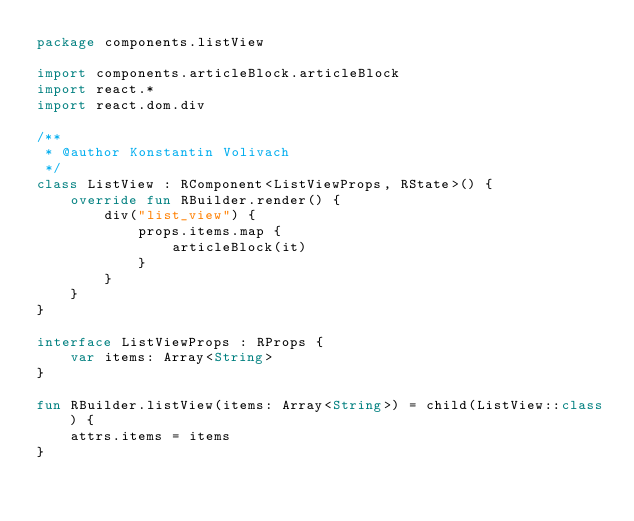<code> <loc_0><loc_0><loc_500><loc_500><_Kotlin_>package components.listView

import components.articleBlock.articleBlock
import react.*
import react.dom.div

/**
 * @author Konstantin Volivach
 */
class ListView : RComponent<ListViewProps, RState>() {
    override fun RBuilder.render() {
        div("list_view") {
            props.items.map {
                articleBlock(it)
            }
        }
    }
}

interface ListViewProps : RProps {
    var items: Array<String>
}

fun RBuilder.listView(items: Array<String>) = child(ListView::class) {
    attrs.items = items
}</code> 